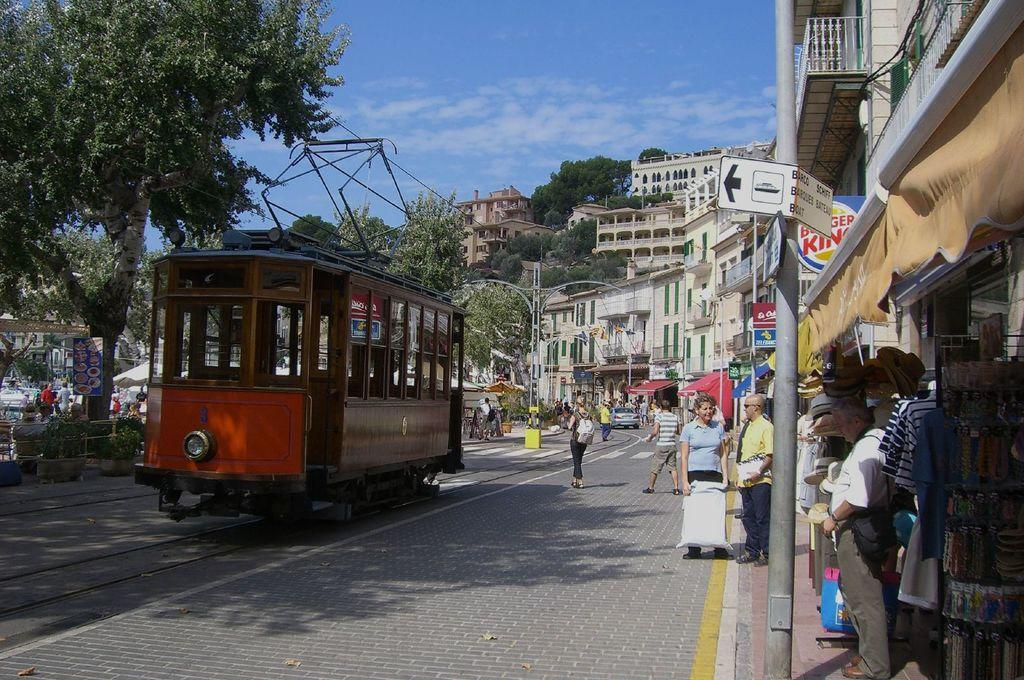<image>
Summarize the visual content of the image. a red trolley in on the street in front of Burger King 